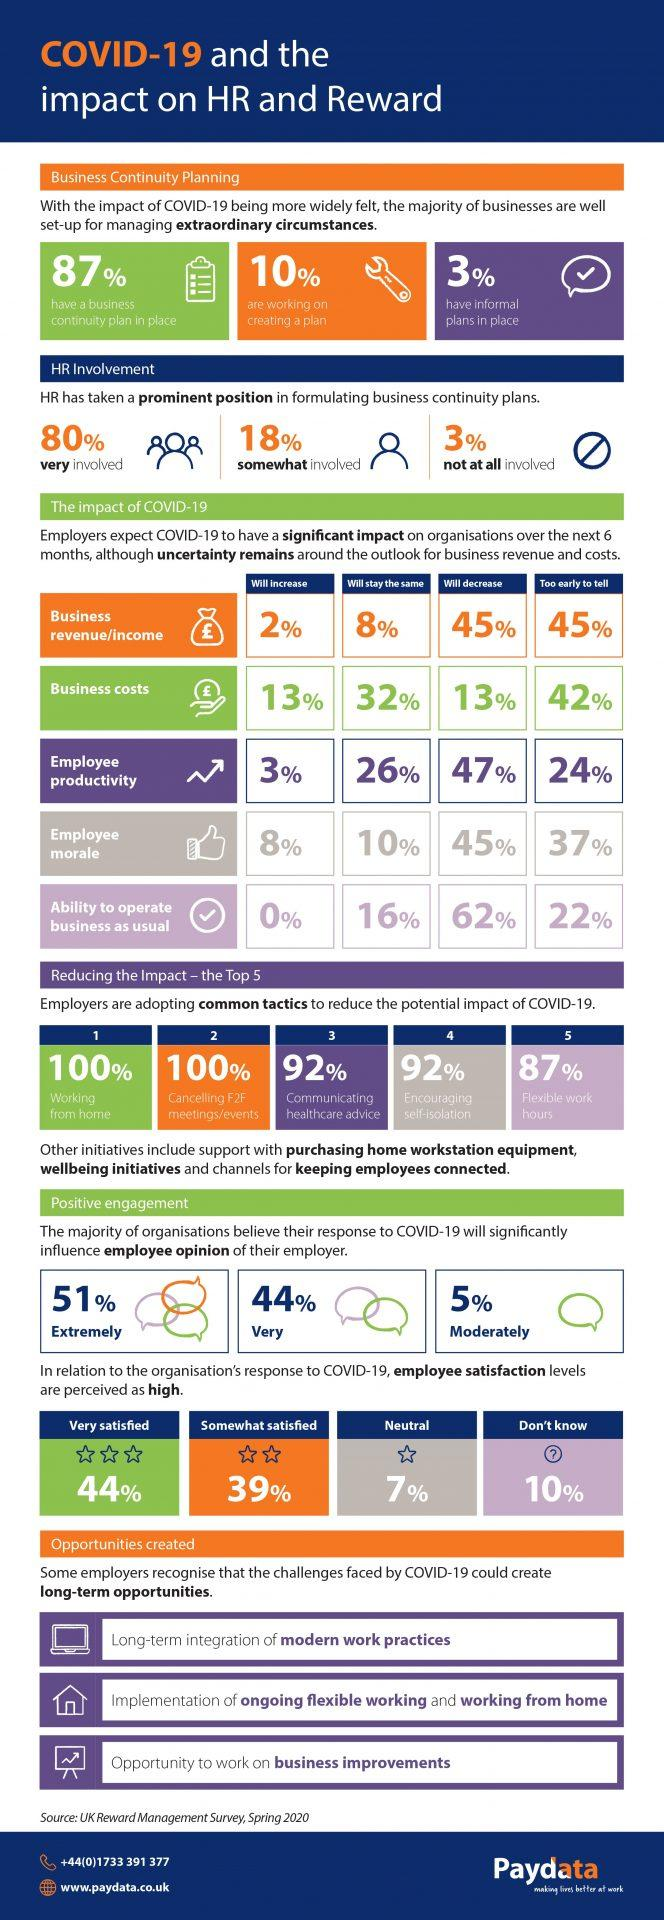List a handful of essential elements in this visual. Eighty-seven percent of the businesses have a business continuity plan in place. In 80% of cases, HR was heavily involved in the development of business continuity plans. A survey of 47% of employers indicates that the productivity of employees will decrease. A survey has found that 87% of employers are adopting flexible work hours. According to the employers surveyed, only 13% believe that business costs will decrease. 